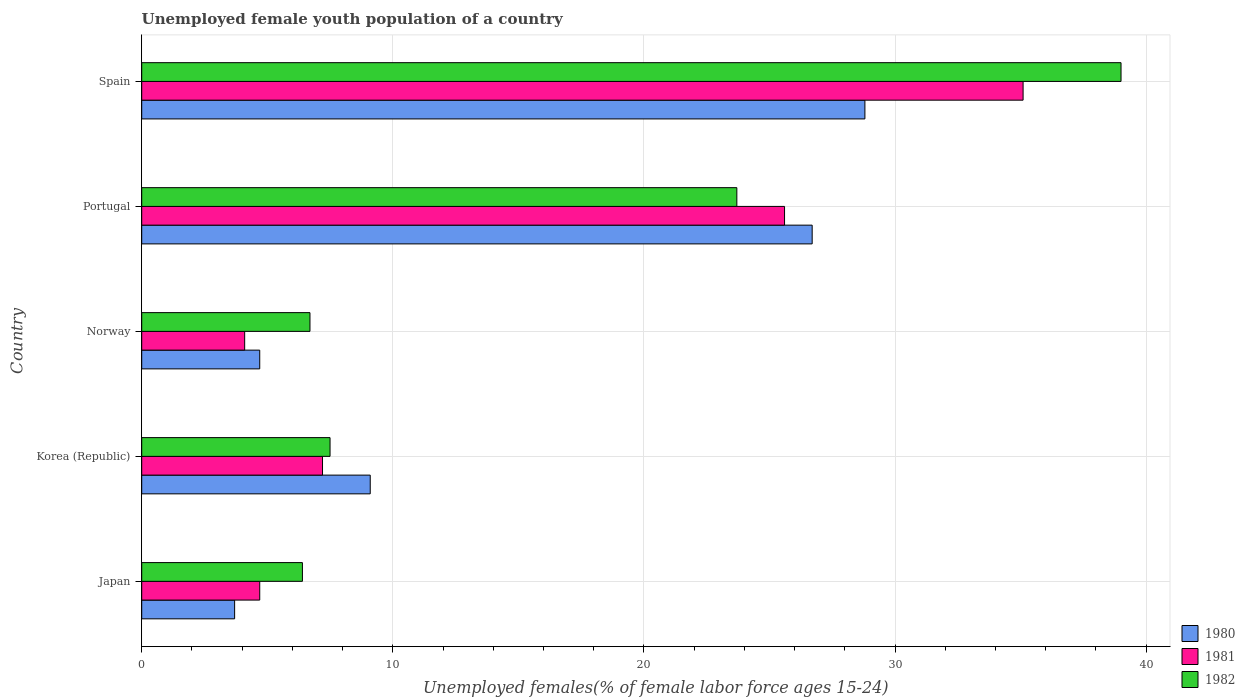How many groups of bars are there?
Ensure brevity in your answer.  5. In how many cases, is the number of bars for a given country not equal to the number of legend labels?
Offer a terse response. 0. What is the percentage of unemployed female youth population in 1982 in Norway?
Provide a succinct answer. 6.7. Across all countries, what is the minimum percentage of unemployed female youth population in 1980?
Ensure brevity in your answer.  3.7. In which country was the percentage of unemployed female youth population in 1981 minimum?
Your answer should be compact. Norway. What is the total percentage of unemployed female youth population in 1980 in the graph?
Provide a short and direct response. 73. What is the difference between the percentage of unemployed female youth population in 1982 in Korea (Republic) and that in Spain?
Your answer should be very brief. -31.5. What is the difference between the percentage of unemployed female youth population in 1982 in Japan and the percentage of unemployed female youth population in 1981 in Korea (Republic)?
Provide a short and direct response. -0.8. What is the average percentage of unemployed female youth population in 1982 per country?
Give a very brief answer. 16.66. What is the difference between the percentage of unemployed female youth population in 1980 and percentage of unemployed female youth population in 1981 in Norway?
Ensure brevity in your answer.  0.6. What is the ratio of the percentage of unemployed female youth population in 1980 in Korea (Republic) to that in Portugal?
Provide a succinct answer. 0.34. Is the percentage of unemployed female youth population in 1980 in Norway less than that in Portugal?
Keep it short and to the point. Yes. Is the difference between the percentage of unemployed female youth population in 1980 in Korea (Republic) and Spain greater than the difference between the percentage of unemployed female youth population in 1981 in Korea (Republic) and Spain?
Your answer should be very brief. Yes. What is the difference between the highest and the second highest percentage of unemployed female youth population in 1980?
Your answer should be very brief. 2.1. What is the difference between the highest and the lowest percentage of unemployed female youth population in 1982?
Your response must be concise. 32.6. Is the sum of the percentage of unemployed female youth population in 1982 in Japan and Norway greater than the maximum percentage of unemployed female youth population in 1980 across all countries?
Give a very brief answer. No. What does the 1st bar from the top in Norway represents?
Give a very brief answer. 1982. What does the 1st bar from the bottom in Norway represents?
Keep it short and to the point. 1980. How many countries are there in the graph?
Your answer should be very brief. 5. Are the values on the major ticks of X-axis written in scientific E-notation?
Provide a short and direct response. No. Does the graph contain any zero values?
Your answer should be very brief. No. Where does the legend appear in the graph?
Give a very brief answer. Bottom right. How are the legend labels stacked?
Provide a succinct answer. Vertical. What is the title of the graph?
Offer a terse response. Unemployed female youth population of a country. What is the label or title of the X-axis?
Your answer should be very brief. Unemployed females(% of female labor force ages 15-24). What is the Unemployed females(% of female labor force ages 15-24) of 1980 in Japan?
Provide a succinct answer. 3.7. What is the Unemployed females(% of female labor force ages 15-24) in 1981 in Japan?
Your answer should be very brief. 4.7. What is the Unemployed females(% of female labor force ages 15-24) in 1982 in Japan?
Offer a very short reply. 6.4. What is the Unemployed females(% of female labor force ages 15-24) in 1980 in Korea (Republic)?
Offer a terse response. 9.1. What is the Unemployed females(% of female labor force ages 15-24) in 1981 in Korea (Republic)?
Keep it short and to the point. 7.2. What is the Unemployed females(% of female labor force ages 15-24) in 1980 in Norway?
Give a very brief answer. 4.7. What is the Unemployed females(% of female labor force ages 15-24) in 1981 in Norway?
Ensure brevity in your answer.  4.1. What is the Unemployed females(% of female labor force ages 15-24) of 1982 in Norway?
Your response must be concise. 6.7. What is the Unemployed females(% of female labor force ages 15-24) in 1980 in Portugal?
Make the answer very short. 26.7. What is the Unemployed females(% of female labor force ages 15-24) in 1981 in Portugal?
Provide a succinct answer. 25.6. What is the Unemployed females(% of female labor force ages 15-24) in 1982 in Portugal?
Offer a terse response. 23.7. What is the Unemployed females(% of female labor force ages 15-24) in 1980 in Spain?
Provide a succinct answer. 28.8. What is the Unemployed females(% of female labor force ages 15-24) of 1981 in Spain?
Provide a succinct answer. 35.1. Across all countries, what is the maximum Unemployed females(% of female labor force ages 15-24) in 1980?
Keep it short and to the point. 28.8. Across all countries, what is the maximum Unemployed females(% of female labor force ages 15-24) of 1981?
Your response must be concise. 35.1. Across all countries, what is the minimum Unemployed females(% of female labor force ages 15-24) of 1980?
Your response must be concise. 3.7. Across all countries, what is the minimum Unemployed females(% of female labor force ages 15-24) of 1981?
Your response must be concise. 4.1. Across all countries, what is the minimum Unemployed females(% of female labor force ages 15-24) in 1982?
Your answer should be compact. 6.4. What is the total Unemployed females(% of female labor force ages 15-24) in 1980 in the graph?
Offer a terse response. 73. What is the total Unemployed females(% of female labor force ages 15-24) of 1981 in the graph?
Your answer should be very brief. 76.7. What is the total Unemployed females(% of female labor force ages 15-24) in 1982 in the graph?
Your answer should be very brief. 83.3. What is the difference between the Unemployed females(% of female labor force ages 15-24) of 1980 in Japan and that in Korea (Republic)?
Your answer should be compact. -5.4. What is the difference between the Unemployed females(% of female labor force ages 15-24) in 1981 in Japan and that in Korea (Republic)?
Your answer should be compact. -2.5. What is the difference between the Unemployed females(% of female labor force ages 15-24) of 1981 in Japan and that in Norway?
Provide a short and direct response. 0.6. What is the difference between the Unemployed females(% of female labor force ages 15-24) in 1982 in Japan and that in Norway?
Ensure brevity in your answer.  -0.3. What is the difference between the Unemployed females(% of female labor force ages 15-24) in 1980 in Japan and that in Portugal?
Your answer should be compact. -23. What is the difference between the Unemployed females(% of female labor force ages 15-24) in 1981 in Japan and that in Portugal?
Offer a very short reply. -20.9. What is the difference between the Unemployed females(% of female labor force ages 15-24) in 1982 in Japan and that in Portugal?
Offer a terse response. -17.3. What is the difference between the Unemployed females(% of female labor force ages 15-24) of 1980 in Japan and that in Spain?
Offer a terse response. -25.1. What is the difference between the Unemployed females(% of female labor force ages 15-24) in 1981 in Japan and that in Spain?
Keep it short and to the point. -30.4. What is the difference between the Unemployed females(% of female labor force ages 15-24) in 1982 in Japan and that in Spain?
Provide a short and direct response. -32.6. What is the difference between the Unemployed females(% of female labor force ages 15-24) of 1981 in Korea (Republic) and that in Norway?
Keep it short and to the point. 3.1. What is the difference between the Unemployed females(% of female labor force ages 15-24) of 1980 in Korea (Republic) and that in Portugal?
Provide a succinct answer. -17.6. What is the difference between the Unemployed females(% of female labor force ages 15-24) in 1981 in Korea (Republic) and that in Portugal?
Provide a short and direct response. -18.4. What is the difference between the Unemployed females(% of female labor force ages 15-24) in 1982 in Korea (Republic) and that in Portugal?
Your answer should be compact. -16.2. What is the difference between the Unemployed females(% of female labor force ages 15-24) in 1980 in Korea (Republic) and that in Spain?
Offer a terse response. -19.7. What is the difference between the Unemployed females(% of female labor force ages 15-24) in 1981 in Korea (Republic) and that in Spain?
Make the answer very short. -27.9. What is the difference between the Unemployed females(% of female labor force ages 15-24) in 1982 in Korea (Republic) and that in Spain?
Provide a succinct answer. -31.5. What is the difference between the Unemployed females(% of female labor force ages 15-24) of 1981 in Norway and that in Portugal?
Provide a short and direct response. -21.5. What is the difference between the Unemployed females(% of female labor force ages 15-24) of 1980 in Norway and that in Spain?
Offer a terse response. -24.1. What is the difference between the Unemployed females(% of female labor force ages 15-24) in 1981 in Norway and that in Spain?
Provide a short and direct response. -31. What is the difference between the Unemployed females(% of female labor force ages 15-24) of 1982 in Norway and that in Spain?
Keep it short and to the point. -32.3. What is the difference between the Unemployed females(% of female labor force ages 15-24) in 1982 in Portugal and that in Spain?
Your response must be concise. -15.3. What is the difference between the Unemployed females(% of female labor force ages 15-24) of 1981 in Japan and the Unemployed females(% of female labor force ages 15-24) of 1982 in Korea (Republic)?
Offer a very short reply. -2.8. What is the difference between the Unemployed females(% of female labor force ages 15-24) in 1980 in Japan and the Unemployed females(% of female labor force ages 15-24) in 1981 in Norway?
Offer a very short reply. -0.4. What is the difference between the Unemployed females(% of female labor force ages 15-24) in 1980 in Japan and the Unemployed females(% of female labor force ages 15-24) in 1982 in Norway?
Give a very brief answer. -3. What is the difference between the Unemployed females(% of female labor force ages 15-24) of 1980 in Japan and the Unemployed females(% of female labor force ages 15-24) of 1981 in Portugal?
Offer a very short reply. -21.9. What is the difference between the Unemployed females(% of female labor force ages 15-24) in 1980 in Japan and the Unemployed females(% of female labor force ages 15-24) in 1981 in Spain?
Provide a short and direct response. -31.4. What is the difference between the Unemployed females(% of female labor force ages 15-24) in 1980 in Japan and the Unemployed females(% of female labor force ages 15-24) in 1982 in Spain?
Give a very brief answer. -35.3. What is the difference between the Unemployed females(% of female labor force ages 15-24) in 1981 in Japan and the Unemployed females(% of female labor force ages 15-24) in 1982 in Spain?
Ensure brevity in your answer.  -34.3. What is the difference between the Unemployed females(% of female labor force ages 15-24) of 1980 in Korea (Republic) and the Unemployed females(% of female labor force ages 15-24) of 1981 in Norway?
Offer a very short reply. 5. What is the difference between the Unemployed females(% of female labor force ages 15-24) in 1980 in Korea (Republic) and the Unemployed females(% of female labor force ages 15-24) in 1981 in Portugal?
Your response must be concise. -16.5. What is the difference between the Unemployed females(% of female labor force ages 15-24) in 1980 in Korea (Republic) and the Unemployed females(% of female labor force ages 15-24) in 1982 in Portugal?
Offer a very short reply. -14.6. What is the difference between the Unemployed females(% of female labor force ages 15-24) of 1981 in Korea (Republic) and the Unemployed females(% of female labor force ages 15-24) of 1982 in Portugal?
Ensure brevity in your answer.  -16.5. What is the difference between the Unemployed females(% of female labor force ages 15-24) in 1980 in Korea (Republic) and the Unemployed females(% of female labor force ages 15-24) in 1981 in Spain?
Your answer should be compact. -26. What is the difference between the Unemployed females(% of female labor force ages 15-24) of 1980 in Korea (Republic) and the Unemployed females(% of female labor force ages 15-24) of 1982 in Spain?
Keep it short and to the point. -29.9. What is the difference between the Unemployed females(% of female labor force ages 15-24) in 1981 in Korea (Republic) and the Unemployed females(% of female labor force ages 15-24) in 1982 in Spain?
Make the answer very short. -31.8. What is the difference between the Unemployed females(% of female labor force ages 15-24) of 1980 in Norway and the Unemployed females(% of female labor force ages 15-24) of 1981 in Portugal?
Your answer should be compact. -20.9. What is the difference between the Unemployed females(% of female labor force ages 15-24) of 1981 in Norway and the Unemployed females(% of female labor force ages 15-24) of 1982 in Portugal?
Provide a succinct answer. -19.6. What is the difference between the Unemployed females(% of female labor force ages 15-24) in 1980 in Norway and the Unemployed females(% of female labor force ages 15-24) in 1981 in Spain?
Give a very brief answer. -30.4. What is the difference between the Unemployed females(% of female labor force ages 15-24) in 1980 in Norway and the Unemployed females(% of female labor force ages 15-24) in 1982 in Spain?
Give a very brief answer. -34.3. What is the difference between the Unemployed females(% of female labor force ages 15-24) in 1981 in Norway and the Unemployed females(% of female labor force ages 15-24) in 1982 in Spain?
Give a very brief answer. -34.9. What is the difference between the Unemployed females(% of female labor force ages 15-24) in 1980 in Portugal and the Unemployed females(% of female labor force ages 15-24) in 1982 in Spain?
Provide a short and direct response. -12.3. What is the average Unemployed females(% of female labor force ages 15-24) of 1981 per country?
Your answer should be very brief. 15.34. What is the average Unemployed females(% of female labor force ages 15-24) of 1982 per country?
Offer a very short reply. 16.66. What is the difference between the Unemployed females(% of female labor force ages 15-24) of 1980 and Unemployed females(% of female labor force ages 15-24) of 1981 in Japan?
Provide a succinct answer. -1. What is the difference between the Unemployed females(% of female labor force ages 15-24) of 1980 and Unemployed females(% of female labor force ages 15-24) of 1982 in Japan?
Your response must be concise. -2.7. What is the difference between the Unemployed females(% of female labor force ages 15-24) of 1980 and Unemployed females(% of female labor force ages 15-24) of 1981 in Korea (Republic)?
Your response must be concise. 1.9. What is the difference between the Unemployed females(% of female labor force ages 15-24) in 1981 and Unemployed females(% of female labor force ages 15-24) in 1982 in Korea (Republic)?
Keep it short and to the point. -0.3. What is the difference between the Unemployed females(% of female labor force ages 15-24) of 1980 and Unemployed females(% of female labor force ages 15-24) of 1982 in Portugal?
Your response must be concise. 3. What is the difference between the Unemployed females(% of female labor force ages 15-24) of 1981 and Unemployed females(% of female labor force ages 15-24) of 1982 in Portugal?
Give a very brief answer. 1.9. What is the difference between the Unemployed females(% of female labor force ages 15-24) of 1980 and Unemployed females(% of female labor force ages 15-24) of 1982 in Spain?
Your answer should be very brief. -10.2. What is the ratio of the Unemployed females(% of female labor force ages 15-24) in 1980 in Japan to that in Korea (Republic)?
Offer a terse response. 0.41. What is the ratio of the Unemployed females(% of female labor force ages 15-24) of 1981 in Japan to that in Korea (Republic)?
Offer a very short reply. 0.65. What is the ratio of the Unemployed females(% of female labor force ages 15-24) in 1982 in Japan to that in Korea (Republic)?
Ensure brevity in your answer.  0.85. What is the ratio of the Unemployed females(% of female labor force ages 15-24) in 1980 in Japan to that in Norway?
Provide a succinct answer. 0.79. What is the ratio of the Unemployed females(% of female labor force ages 15-24) in 1981 in Japan to that in Norway?
Keep it short and to the point. 1.15. What is the ratio of the Unemployed females(% of female labor force ages 15-24) in 1982 in Japan to that in Norway?
Keep it short and to the point. 0.96. What is the ratio of the Unemployed females(% of female labor force ages 15-24) of 1980 in Japan to that in Portugal?
Your response must be concise. 0.14. What is the ratio of the Unemployed females(% of female labor force ages 15-24) in 1981 in Japan to that in Portugal?
Provide a short and direct response. 0.18. What is the ratio of the Unemployed females(% of female labor force ages 15-24) of 1982 in Japan to that in Portugal?
Ensure brevity in your answer.  0.27. What is the ratio of the Unemployed females(% of female labor force ages 15-24) of 1980 in Japan to that in Spain?
Provide a short and direct response. 0.13. What is the ratio of the Unemployed females(% of female labor force ages 15-24) of 1981 in Japan to that in Spain?
Offer a very short reply. 0.13. What is the ratio of the Unemployed females(% of female labor force ages 15-24) in 1982 in Japan to that in Spain?
Your answer should be very brief. 0.16. What is the ratio of the Unemployed females(% of female labor force ages 15-24) in 1980 in Korea (Republic) to that in Norway?
Your response must be concise. 1.94. What is the ratio of the Unemployed females(% of female labor force ages 15-24) in 1981 in Korea (Republic) to that in Norway?
Provide a succinct answer. 1.76. What is the ratio of the Unemployed females(% of female labor force ages 15-24) of 1982 in Korea (Republic) to that in Norway?
Provide a succinct answer. 1.12. What is the ratio of the Unemployed females(% of female labor force ages 15-24) of 1980 in Korea (Republic) to that in Portugal?
Provide a short and direct response. 0.34. What is the ratio of the Unemployed females(% of female labor force ages 15-24) in 1981 in Korea (Republic) to that in Portugal?
Your answer should be very brief. 0.28. What is the ratio of the Unemployed females(% of female labor force ages 15-24) in 1982 in Korea (Republic) to that in Portugal?
Offer a terse response. 0.32. What is the ratio of the Unemployed females(% of female labor force ages 15-24) of 1980 in Korea (Republic) to that in Spain?
Provide a short and direct response. 0.32. What is the ratio of the Unemployed females(% of female labor force ages 15-24) of 1981 in Korea (Republic) to that in Spain?
Make the answer very short. 0.21. What is the ratio of the Unemployed females(% of female labor force ages 15-24) in 1982 in Korea (Republic) to that in Spain?
Your answer should be compact. 0.19. What is the ratio of the Unemployed females(% of female labor force ages 15-24) in 1980 in Norway to that in Portugal?
Provide a succinct answer. 0.18. What is the ratio of the Unemployed females(% of female labor force ages 15-24) in 1981 in Norway to that in Portugal?
Make the answer very short. 0.16. What is the ratio of the Unemployed females(% of female labor force ages 15-24) of 1982 in Norway to that in Portugal?
Provide a succinct answer. 0.28. What is the ratio of the Unemployed females(% of female labor force ages 15-24) in 1980 in Norway to that in Spain?
Provide a short and direct response. 0.16. What is the ratio of the Unemployed females(% of female labor force ages 15-24) in 1981 in Norway to that in Spain?
Your answer should be compact. 0.12. What is the ratio of the Unemployed females(% of female labor force ages 15-24) in 1982 in Norway to that in Spain?
Provide a short and direct response. 0.17. What is the ratio of the Unemployed females(% of female labor force ages 15-24) in 1980 in Portugal to that in Spain?
Offer a very short reply. 0.93. What is the ratio of the Unemployed females(% of female labor force ages 15-24) in 1981 in Portugal to that in Spain?
Your answer should be very brief. 0.73. What is the ratio of the Unemployed females(% of female labor force ages 15-24) in 1982 in Portugal to that in Spain?
Your answer should be compact. 0.61. What is the difference between the highest and the second highest Unemployed females(% of female labor force ages 15-24) in 1981?
Keep it short and to the point. 9.5. What is the difference between the highest and the second highest Unemployed females(% of female labor force ages 15-24) in 1982?
Your answer should be compact. 15.3. What is the difference between the highest and the lowest Unemployed females(% of female labor force ages 15-24) in 1980?
Provide a short and direct response. 25.1. What is the difference between the highest and the lowest Unemployed females(% of female labor force ages 15-24) of 1981?
Your answer should be compact. 31. What is the difference between the highest and the lowest Unemployed females(% of female labor force ages 15-24) in 1982?
Ensure brevity in your answer.  32.6. 